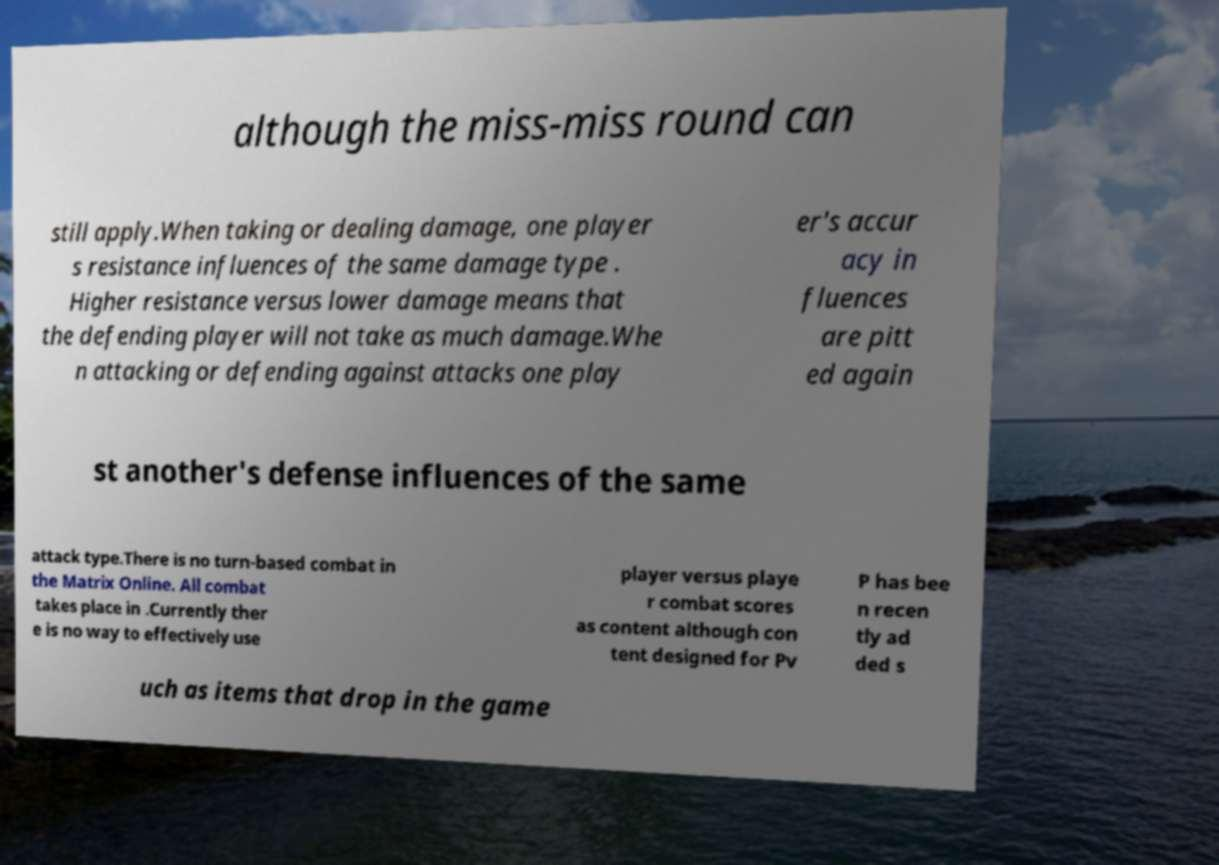Please identify and transcribe the text found in this image. although the miss-miss round can still apply.When taking or dealing damage, one player s resistance influences of the same damage type . Higher resistance versus lower damage means that the defending player will not take as much damage.Whe n attacking or defending against attacks one play er's accur acy in fluences are pitt ed again st another's defense influences of the same attack type.There is no turn-based combat in the Matrix Online. All combat takes place in .Currently ther e is no way to effectively use player versus playe r combat scores as content although con tent designed for Pv P has bee n recen tly ad ded s uch as items that drop in the game 